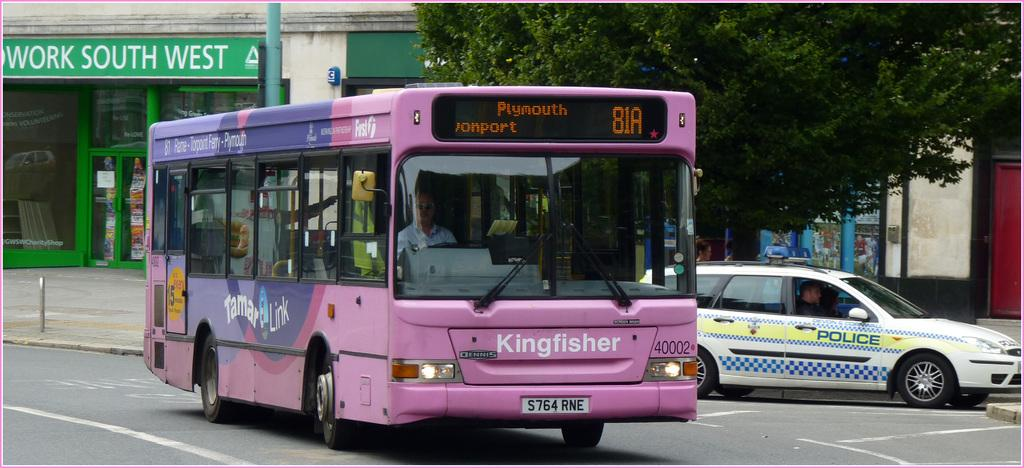<image>
Give a short and clear explanation of the subsequent image. A ping bus that says Kingfisher on its front. 